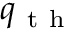<formula> <loc_0><loc_0><loc_500><loc_500>q _ { t h }</formula> 